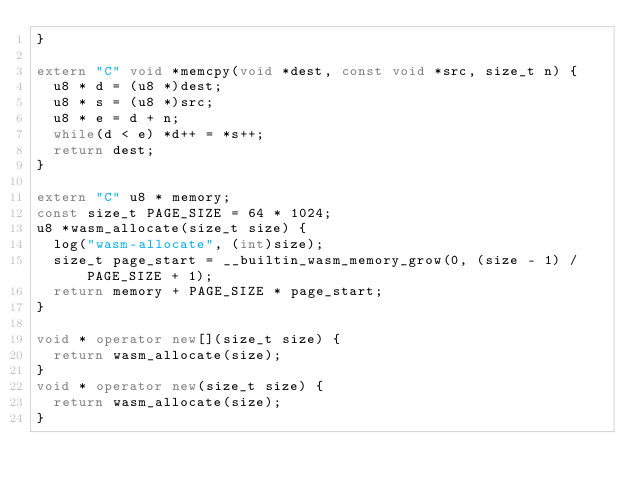<code> <loc_0><loc_0><loc_500><loc_500><_C++_>}

extern "C" void *memcpy(void *dest, const void *src, size_t n) {
  u8 * d = (u8 *)dest;
  u8 * s = (u8 *)src;
  u8 * e = d + n;
  while(d < e) *d++ = *s++;
  return dest;
}

extern "C" u8 * memory;
const size_t PAGE_SIZE = 64 * 1024;
u8 *wasm_allocate(size_t size) {
  log("wasm-allocate", (int)size);
  size_t page_start = __builtin_wasm_memory_grow(0, (size - 1) / PAGE_SIZE + 1);
  return memory + PAGE_SIZE * page_start;
}

void * operator new[](size_t size) {
  return wasm_allocate(size);
}
void * operator new(size_t size) {
  return wasm_allocate(size);
}
</code> 